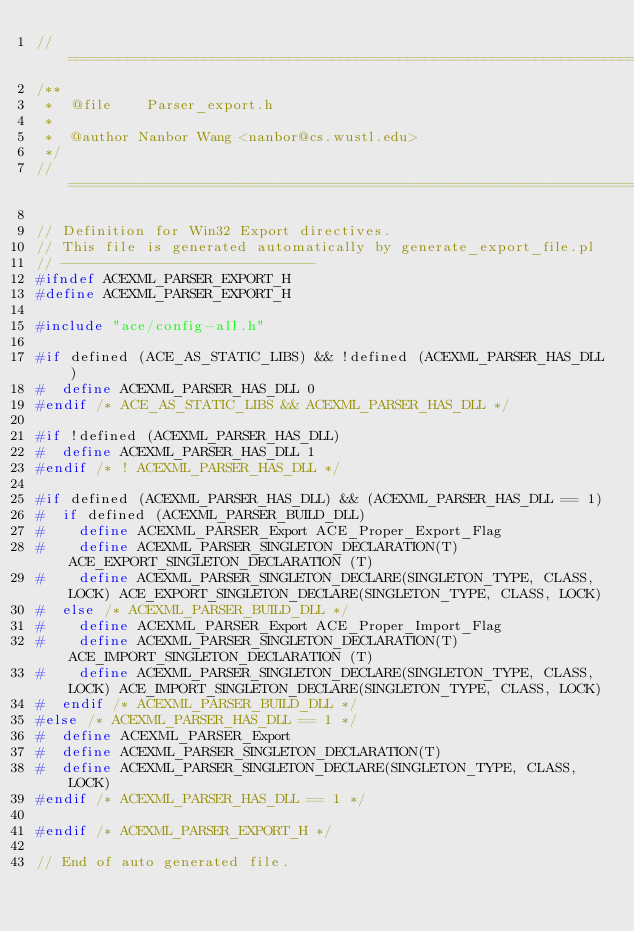Convert code to text. <code><loc_0><loc_0><loc_500><loc_500><_C_>//=============================================================================
/**
 *  @file    Parser_export.h
 *
 *  @author Nanbor Wang <nanbor@cs.wustl.edu>
 */
//=============================================================================

// Definition for Win32 Export directives.
// This file is generated automatically by generate_export_file.pl
// ------------------------------
#ifndef ACEXML_PARSER_EXPORT_H
#define ACEXML_PARSER_EXPORT_H

#include "ace/config-all.h"

#if defined (ACE_AS_STATIC_LIBS) && !defined (ACEXML_PARSER_HAS_DLL)
#  define ACEXML_PARSER_HAS_DLL 0
#endif /* ACE_AS_STATIC_LIBS && ACEXML_PARSER_HAS_DLL */

#if !defined (ACEXML_PARSER_HAS_DLL)
#  define ACEXML_PARSER_HAS_DLL 1
#endif /* ! ACEXML_PARSER_HAS_DLL */

#if defined (ACEXML_PARSER_HAS_DLL) && (ACEXML_PARSER_HAS_DLL == 1)
#  if defined (ACEXML_PARSER_BUILD_DLL)
#    define ACEXML_PARSER_Export ACE_Proper_Export_Flag
#    define ACEXML_PARSER_SINGLETON_DECLARATION(T) ACE_EXPORT_SINGLETON_DECLARATION (T)
#    define ACEXML_PARSER_SINGLETON_DECLARE(SINGLETON_TYPE, CLASS, LOCK) ACE_EXPORT_SINGLETON_DECLARE(SINGLETON_TYPE, CLASS, LOCK)
#  else /* ACEXML_PARSER_BUILD_DLL */
#    define ACEXML_PARSER_Export ACE_Proper_Import_Flag
#    define ACEXML_PARSER_SINGLETON_DECLARATION(T) ACE_IMPORT_SINGLETON_DECLARATION (T)
#    define ACEXML_PARSER_SINGLETON_DECLARE(SINGLETON_TYPE, CLASS, LOCK) ACE_IMPORT_SINGLETON_DECLARE(SINGLETON_TYPE, CLASS, LOCK)
#  endif /* ACEXML_PARSER_BUILD_DLL */
#else /* ACEXML_PARSER_HAS_DLL == 1 */
#  define ACEXML_PARSER_Export
#  define ACEXML_PARSER_SINGLETON_DECLARATION(T)
#  define ACEXML_PARSER_SINGLETON_DECLARE(SINGLETON_TYPE, CLASS, LOCK)
#endif /* ACEXML_PARSER_HAS_DLL == 1 */

#endif /* ACEXML_PARSER_EXPORT_H */

// End of auto generated file.
</code> 